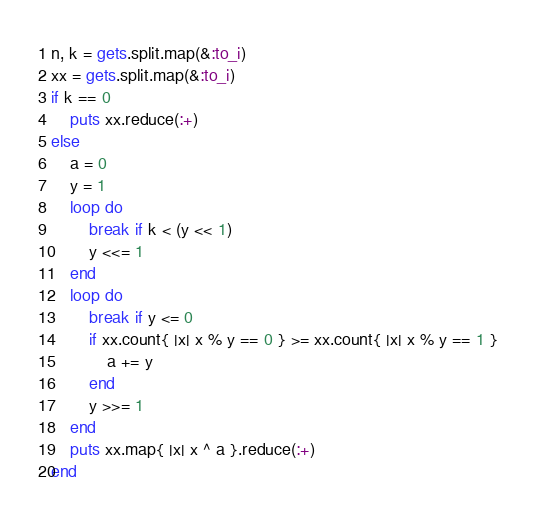<code> <loc_0><loc_0><loc_500><loc_500><_Ruby_>n, k = gets.split.map(&:to_i)
xx = gets.split.map(&:to_i)
if k == 0
    puts xx.reduce(:+)
else
    a = 0
    y = 1
    loop do
        break if k < (y << 1)
        y <<= 1
    end
    loop do
        break if y <= 0
        if xx.count{ |x| x % y == 0 } >= xx.count{ |x| x % y == 1 }
            a += y
        end
        y >>= 1
    end
    puts xx.map{ |x| x ^ a }.reduce(:+)
end

</code> 